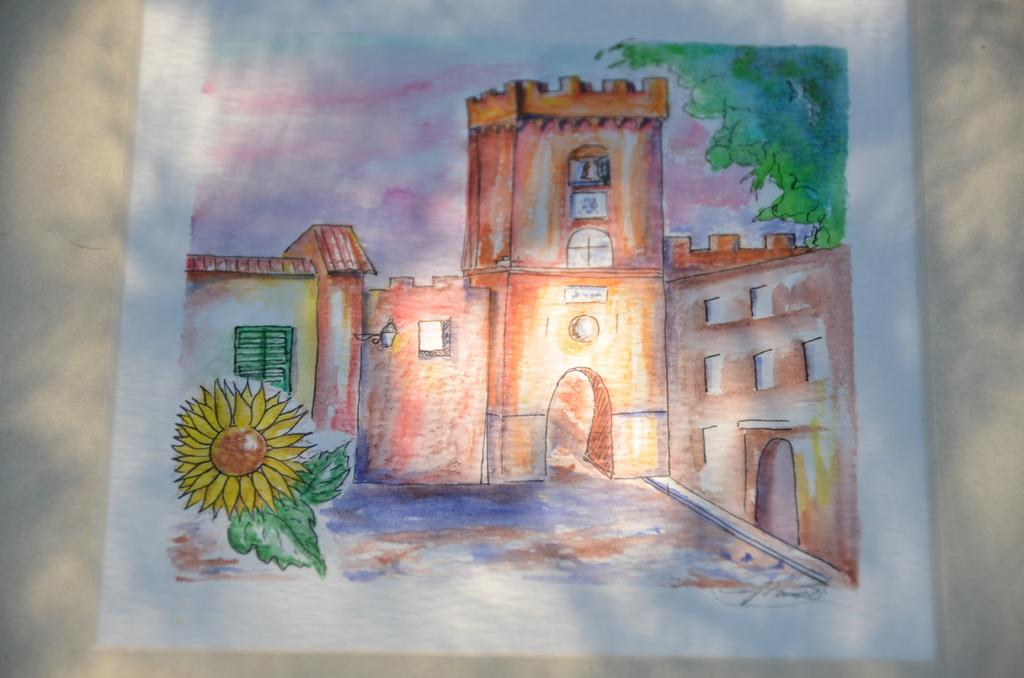What is the main subject of the painting in the image? The painting depicts a building. What other elements are present in the painting? The painting also depicts a tree, a flower, land, and the sky. How many chains can be seen hanging from the tree in the painting? There are no chains present in the painting; it depicts a tree without any chains. 